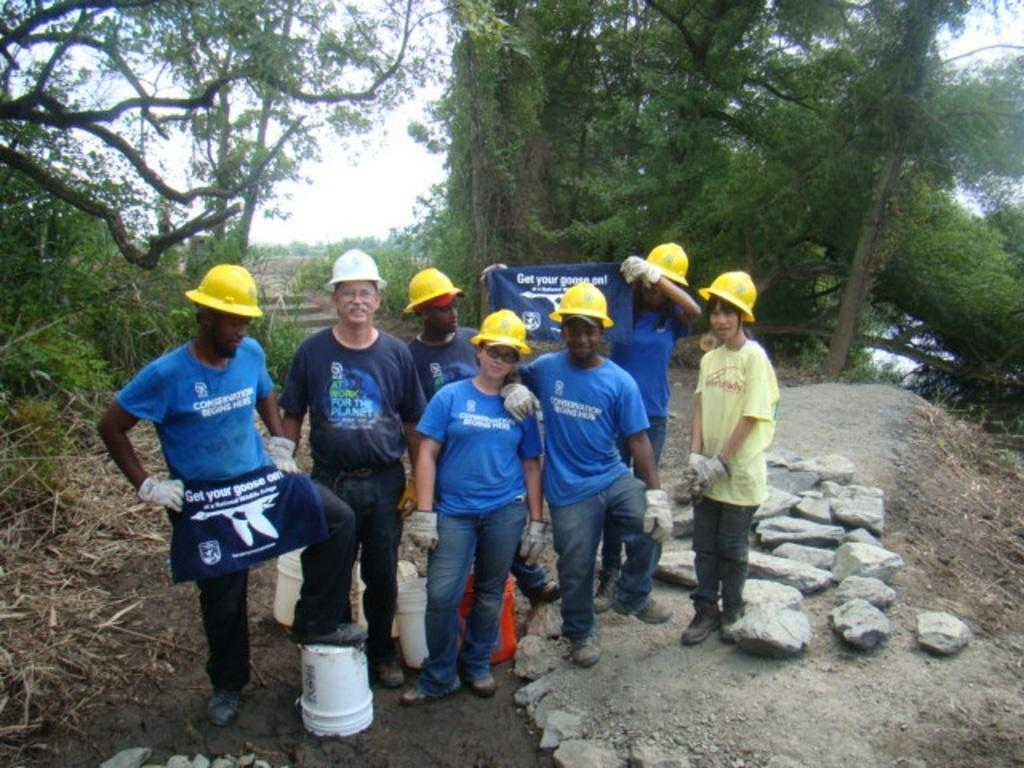Provide a one-sentence caption for the provided image. A group of people in yellow hard hats are holding shirts that say Get your goose on. 